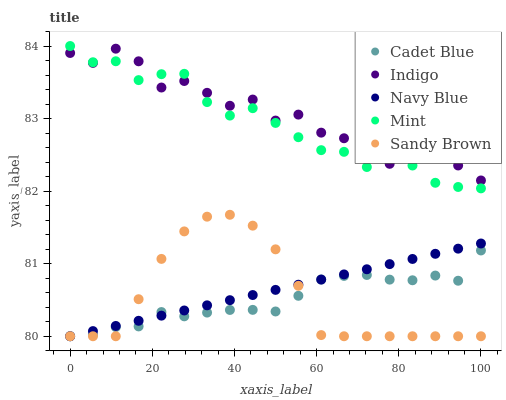Does Cadet Blue have the minimum area under the curve?
Answer yes or no. Yes. Does Indigo have the maximum area under the curve?
Answer yes or no. Yes. Does Indigo have the minimum area under the curve?
Answer yes or no. No. Does Cadet Blue have the maximum area under the curve?
Answer yes or no. No. Is Navy Blue the smoothest?
Answer yes or no. Yes. Is Indigo the roughest?
Answer yes or no. Yes. Is Cadet Blue the smoothest?
Answer yes or no. No. Is Cadet Blue the roughest?
Answer yes or no. No. Does Navy Blue have the lowest value?
Answer yes or no. Yes. Does Indigo have the lowest value?
Answer yes or no. No. Does Mint have the highest value?
Answer yes or no. Yes. Does Indigo have the highest value?
Answer yes or no. No. Is Navy Blue less than Indigo?
Answer yes or no. Yes. Is Mint greater than Cadet Blue?
Answer yes or no. Yes. Does Cadet Blue intersect Navy Blue?
Answer yes or no. Yes. Is Cadet Blue less than Navy Blue?
Answer yes or no. No. Is Cadet Blue greater than Navy Blue?
Answer yes or no. No. Does Navy Blue intersect Indigo?
Answer yes or no. No. 